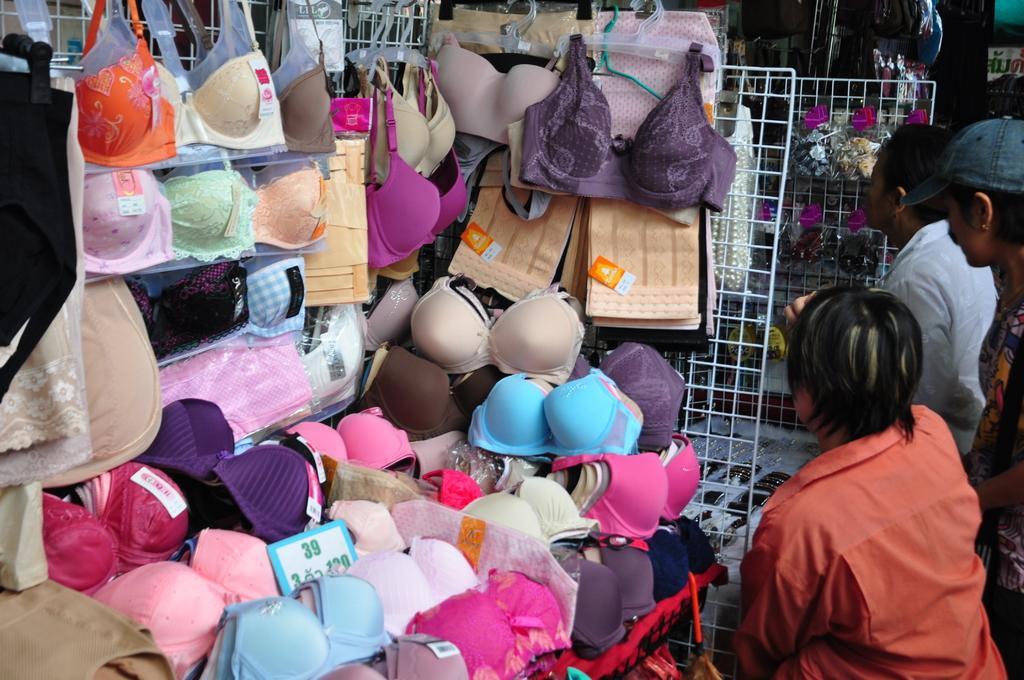Could you give a brief overview of what you see in this image? In the picture I can see few inner wears in the left corner and there are few persons standing in the right corner and there are some other objects in the background. 